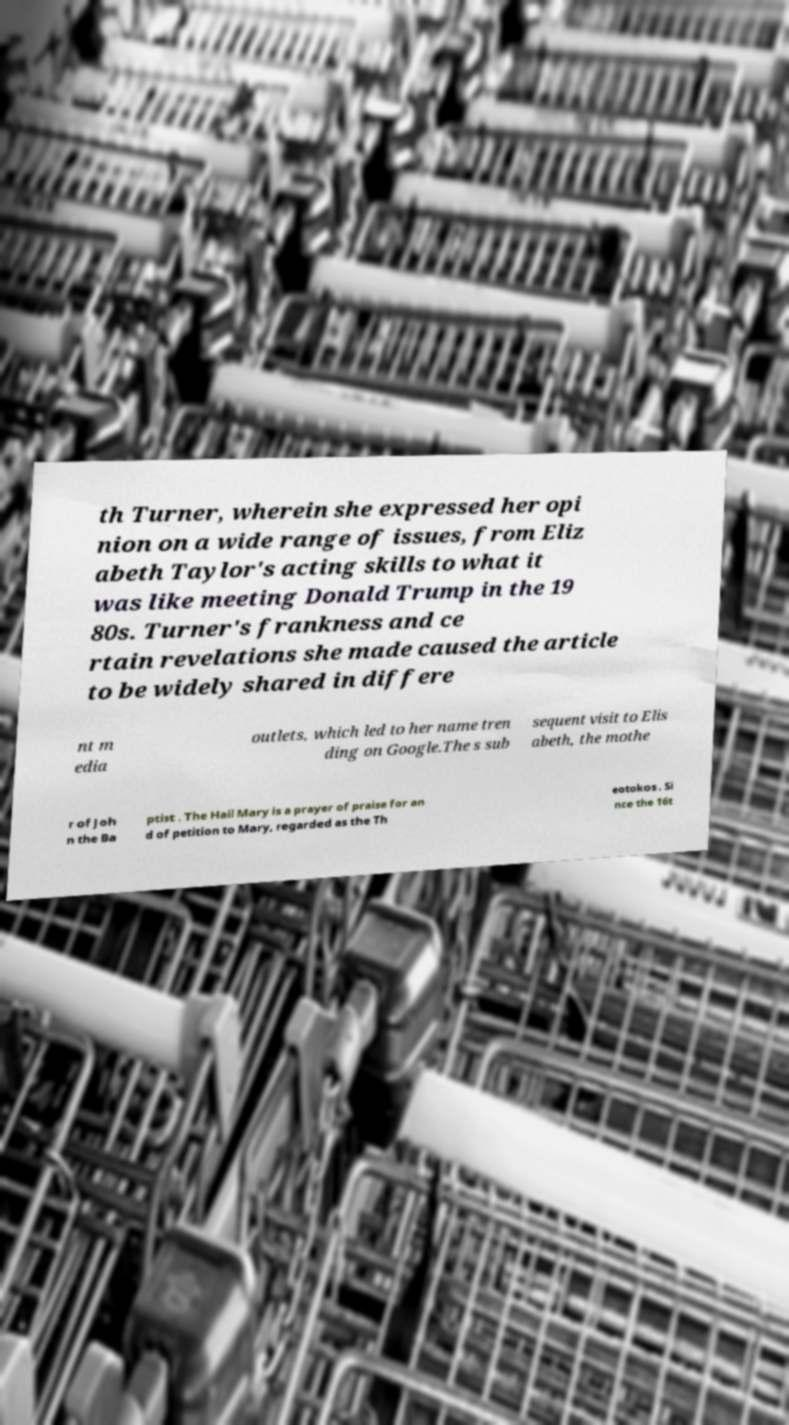I need the written content from this picture converted into text. Can you do that? th Turner, wherein she expressed her opi nion on a wide range of issues, from Eliz abeth Taylor's acting skills to what it was like meeting Donald Trump in the 19 80s. Turner's frankness and ce rtain revelations she made caused the article to be widely shared in differe nt m edia outlets, which led to her name tren ding on Google.The s sub sequent visit to Elis abeth, the mothe r of Joh n the Ba ptist . The Hail Mary is a prayer of praise for an d of petition to Mary, regarded as the Th eotokos . Si nce the 16t 